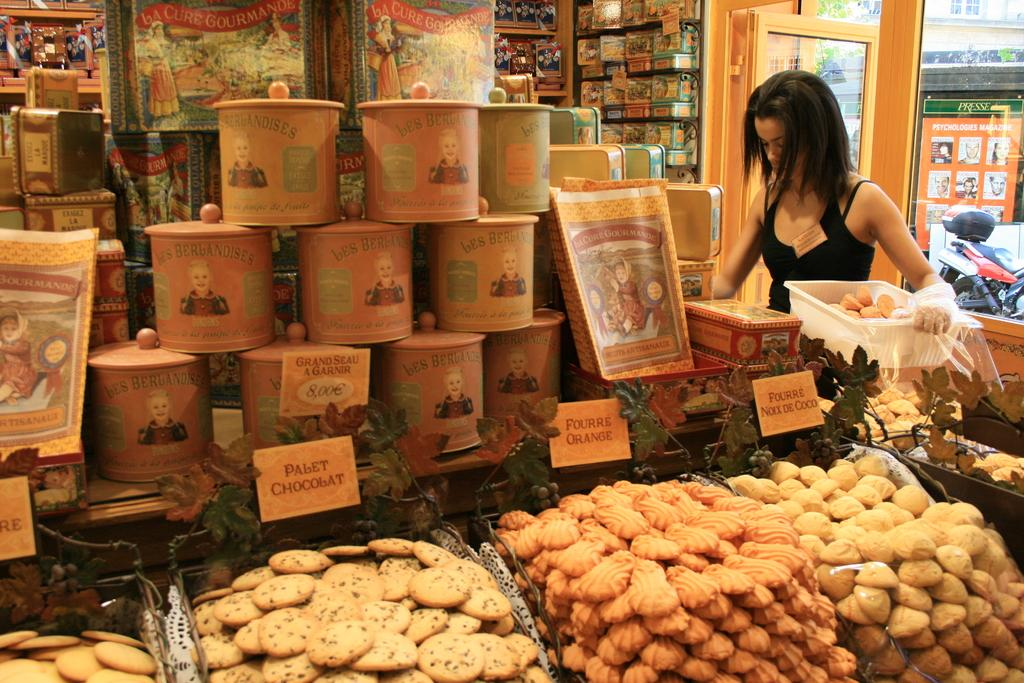<image>
Present a compact description of the photo's key features. A store sells many fresh cookies including Palet Chocolat, Fourre Orange, and Fourre Noix de Coco varieties. 